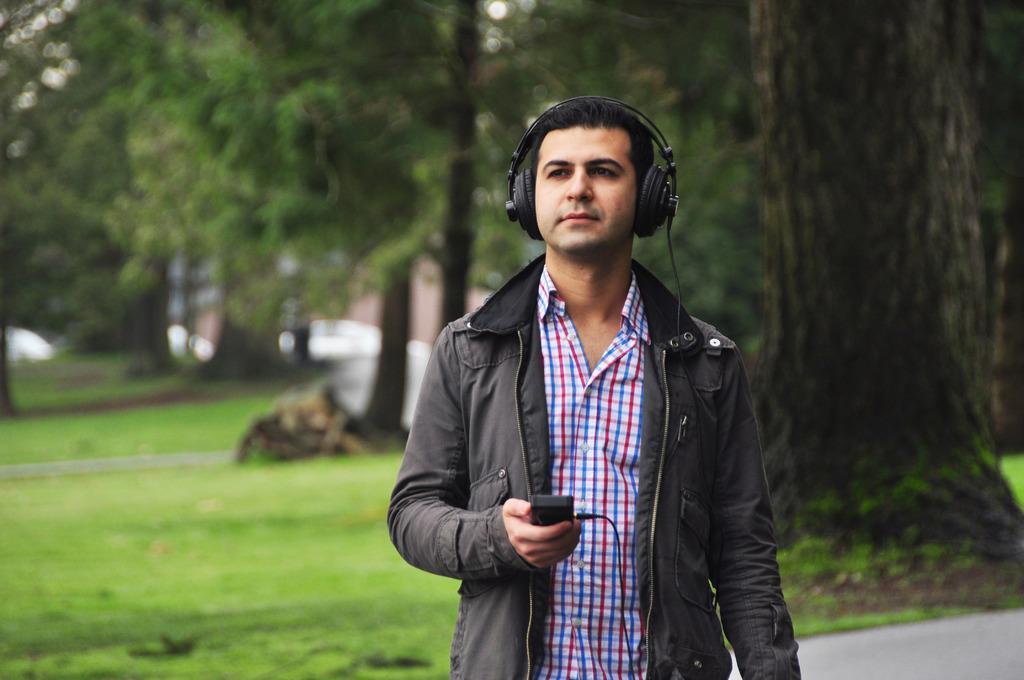How would you summarize this image in a sentence or two? In this image, we can see a person wearing headphones is holding an object. We can also see the ground. We can see some grass and trees. 